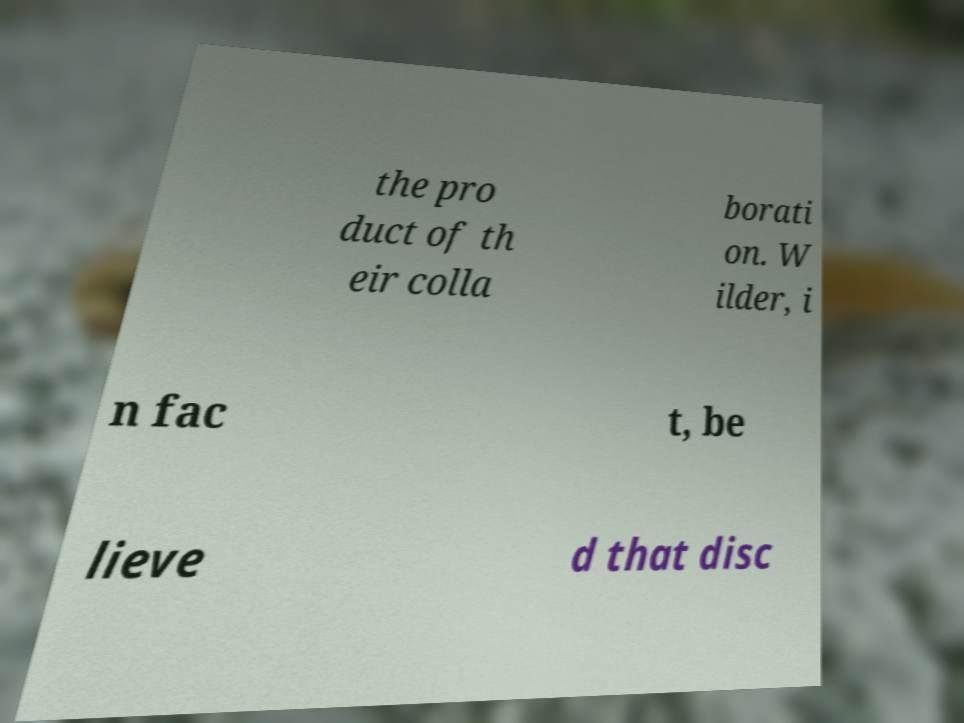For documentation purposes, I need the text within this image transcribed. Could you provide that? the pro duct of th eir colla borati on. W ilder, i n fac t, be lieve d that disc 